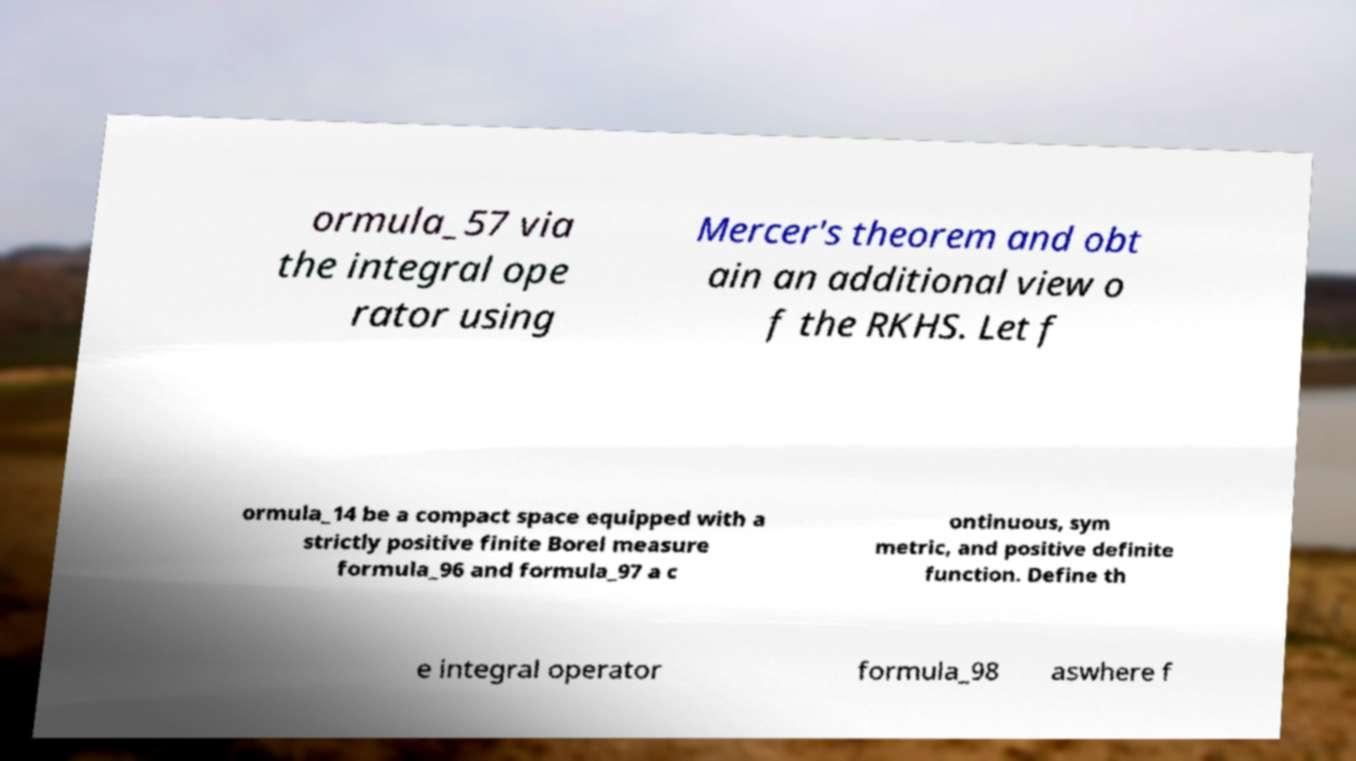There's text embedded in this image that I need extracted. Can you transcribe it verbatim? ormula_57 via the integral ope rator using Mercer's theorem and obt ain an additional view o f the RKHS. Let f ormula_14 be a compact space equipped with a strictly positive finite Borel measure formula_96 and formula_97 a c ontinuous, sym metric, and positive definite function. Define th e integral operator formula_98 aswhere f 